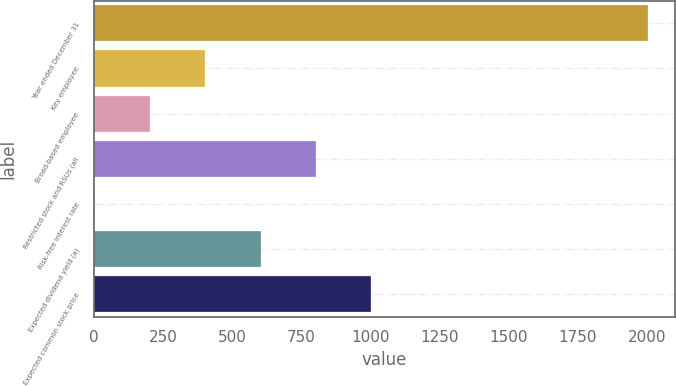Convert chart to OTSL. <chart><loc_0><loc_0><loc_500><loc_500><bar_chart><fcel>Year ended December 31<fcel>Key employee<fcel>Broad-based employee<fcel>Restricted stock and RSUs (all<fcel>Risk-free interest rate<fcel>Expected dividend yield (a)<fcel>Expected common stock price<nl><fcel>2003<fcel>403.15<fcel>203.17<fcel>803.11<fcel>3.19<fcel>603.13<fcel>1003.09<nl></chart> 